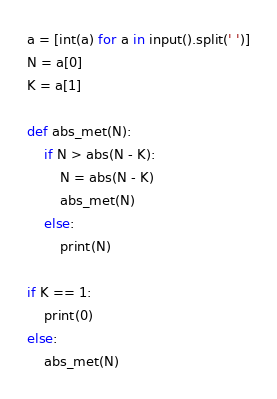<code> <loc_0><loc_0><loc_500><loc_500><_Python_>a = [int(a) for a in input().split(' ')]
N = a[0]
K = a[1]
    
def abs_met(N):
    if N > abs(N - K):
        N = abs(N - K)
        abs_met(N)
    else:
        print(N)
        
if K == 1:
    print(0)
else:
    abs_met(N)</code> 